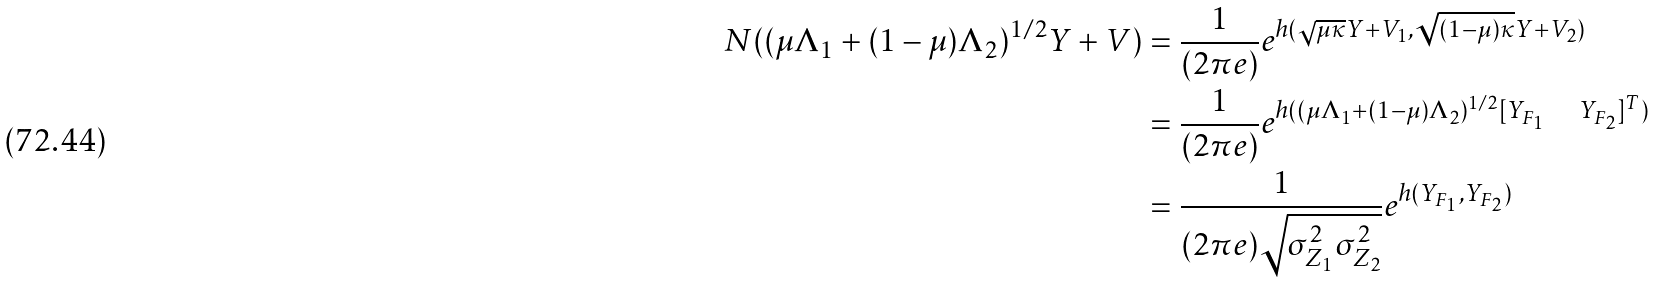<formula> <loc_0><loc_0><loc_500><loc_500>N ( ( \mu \Lambda _ { 1 } + ( 1 - \mu ) \Lambda _ { 2 } ) ^ { 1 / 2 } Y + V ) & = \frac { 1 } { ( 2 \pi e ) } e ^ { h ( \sqrt { \mu \kappa } Y + V _ { 1 } , \sqrt { ( 1 - \mu ) \kappa } Y + V _ { 2 } ) } \\ & = \frac { 1 } { ( 2 \pi e ) } e ^ { h ( ( \mu \Lambda _ { 1 } + ( 1 - \mu ) \Lambda _ { 2 } ) ^ { 1 / 2 } [ Y _ { F _ { 1 } } \quad Y _ { F _ { 2 } } ] ^ { T } ) } \\ & = \frac { 1 } { ( 2 \pi e ) \sqrt { \sigma _ { Z _ { 1 } } ^ { 2 } \sigma _ { Z _ { 2 } } ^ { 2 } } } e ^ { h ( Y _ { F _ { 1 } } , Y _ { F _ { 2 } } ) }</formula> 